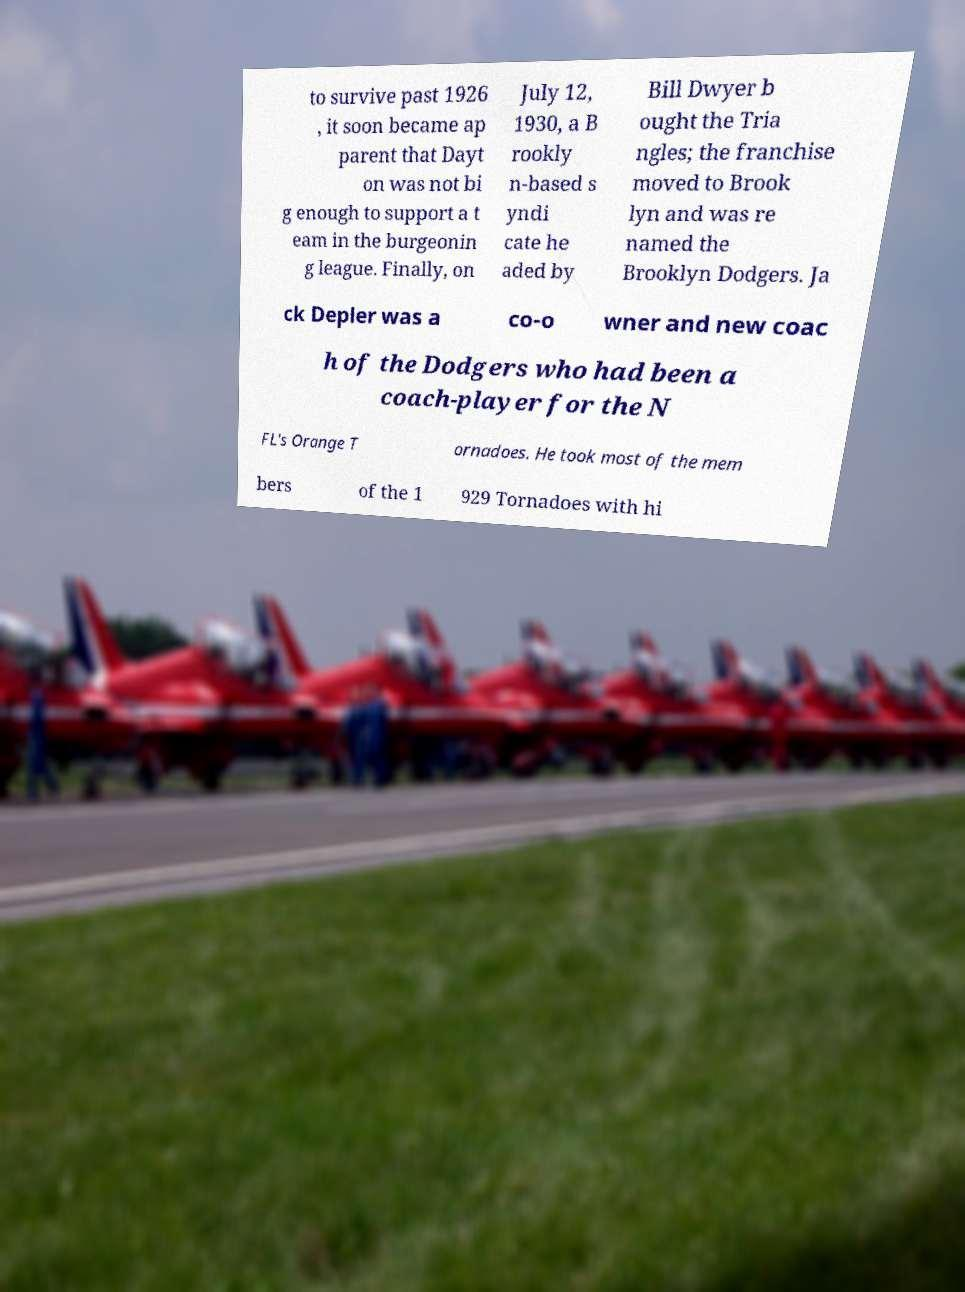For documentation purposes, I need the text within this image transcribed. Could you provide that? to survive past 1926 , it soon became ap parent that Dayt on was not bi g enough to support a t eam in the burgeonin g league. Finally, on July 12, 1930, a B rookly n-based s yndi cate he aded by Bill Dwyer b ought the Tria ngles; the franchise moved to Brook lyn and was re named the Brooklyn Dodgers. Ja ck Depler was a co-o wner and new coac h of the Dodgers who had been a coach-player for the N FL's Orange T ornadoes. He took most of the mem bers of the 1 929 Tornadoes with hi 